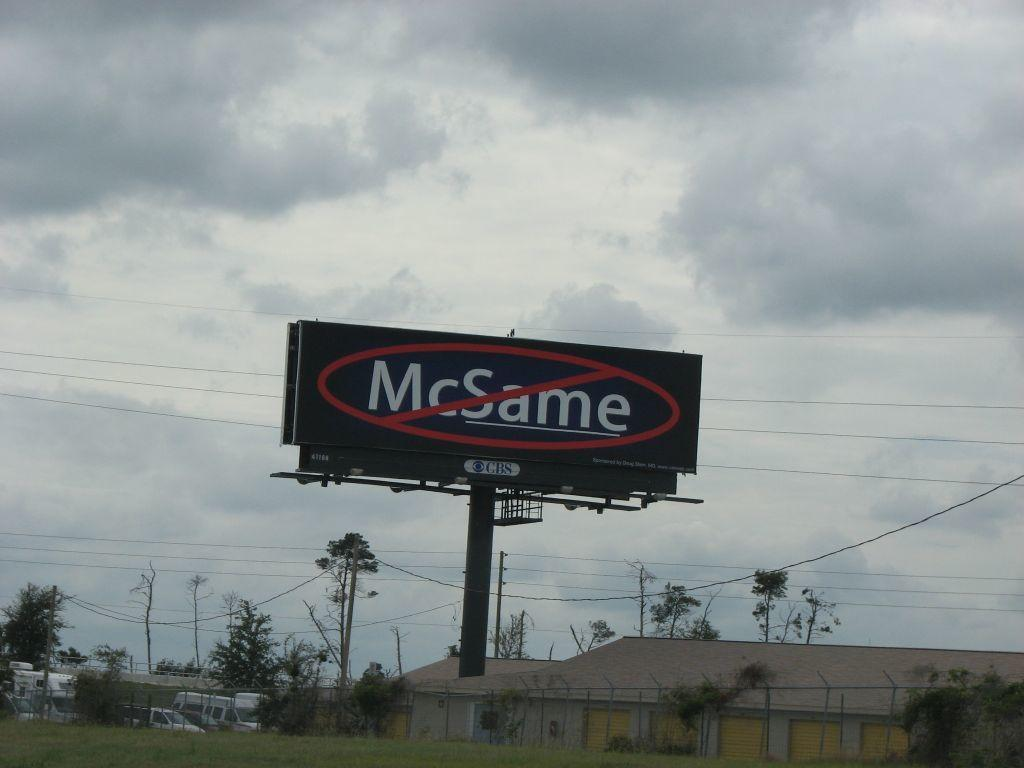Provide a one-sentence caption for the provided image. The huge billboard urged no more of the McSame!. 